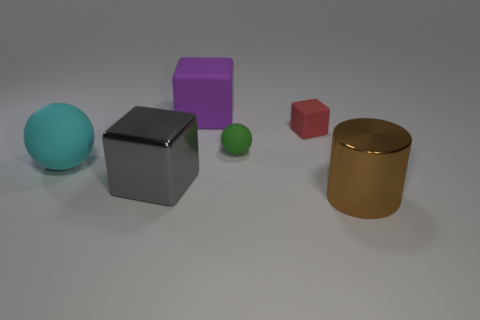Can you tell the relative sizes of these objects? Yes, there is a clear difference in size among the objects in the image. The large teal sphere and the big grey cube are the largest, followed by the golden cylinder. The purple cube is smaller in comparison to these three. The red cube and the small green sphere are the tiniest objects in the scene. Compared to the red cube, how big is the green sphere? The green sphere appears to be slightly smaller than the red cube when comparing their size directly. Due to the perspectives and possibly the distances between the objects, it's hard to provide precise dimensions, but visually the green sphere has a smaller diameter than the side length of the red cube. 